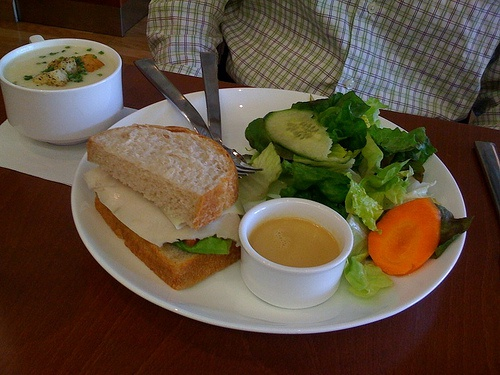Describe the objects in this image and their specific colors. I can see dining table in black, maroon, darkgray, and gray tones, people in black, gray, and darkgreen tones, sandwich in black, gray, olive, and maroon tones, bowl in black, gray, and darkgray tones, and bowl in black, darkgray, olive, and gray tones in this image. 